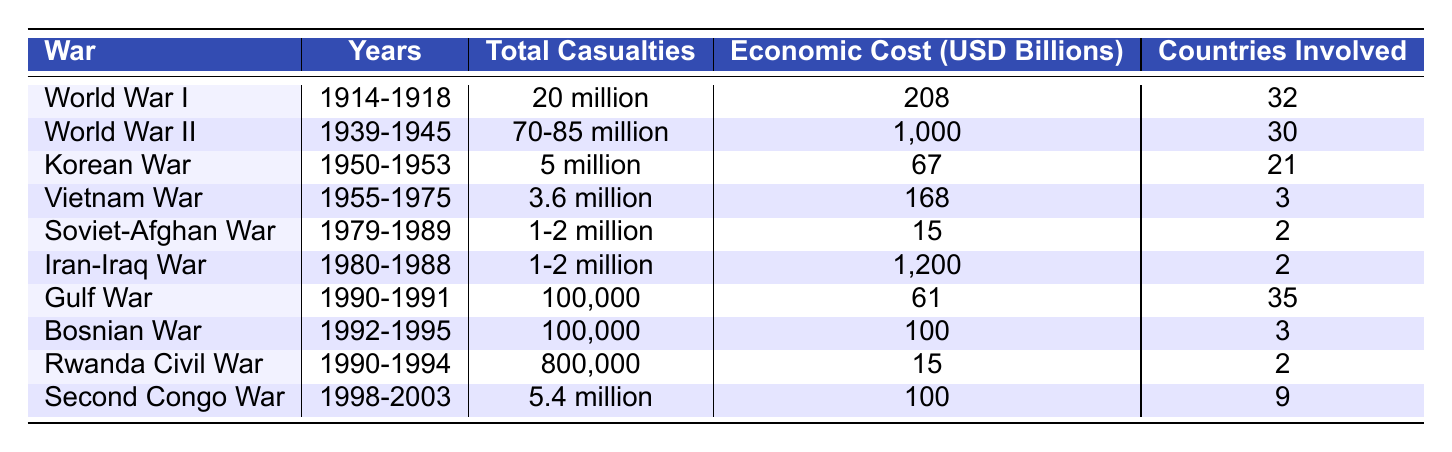What war had the highest total casualties? From the table, World War II has the total casualties listed as 70-85 million, which is higher than any other war listed.
Answer: World War II What was the economic cost of the Korean War? The table shows that the economic cost of the Korean War is listed as 67 billion USD.
Answer: 67 billion USD How many countries were involved in the Iran-Iraq War? According to the table, there were 2 countries involved in the Iran-Iraq War.
Answer: 2 What is the total casualties of the Gulf War compared to the Second Congo War? The Gulf War had 100,000 casualties, while the Second Congo War had 5.4 million. The Second Congo War had significantly more casualties than the Gulf War.
Answer: Second Congo War had more casualties What is the difference in economic cost between World War I and World War II? The economic cost of World War II is 1,000 billion USD and World War I is 208 billion USD. The difference is 1,000 - 208 = 792 billion USD.
Answer: 792 billion USD Which war had the lowest reported economic cost? Looking at the table, the Soviet-Afghan War had the lowest reported economic cost at 15 billion USD.
Answer: Soviet-Afghan War What is the average economic cost of the wars listed in the table? To find the average, we need to sum up the economic costs: 208 + 1,000 + 67 + 168 + 15 + 1,200 + 61 + 100 + 15 + 100 = 2,934 billion USD. Then, divide by the number of wars (10) to get 2,934 / 10 = 293.4 billion USD.
Answer: 293.4 billion USD Is it true that all wars listed had more than 100,000 casualties? From the table, the Gulf War and the Bosnian War both had 100,000 casualties, which means not all had more than 100,000 casualties. Therefore, it is false.
Answer: False Which war had economic costs exceeding 100 billion USD? The wars with economic costs exceeding 100 billion USD are World War II (1,000 billion USD), Iran-Iraq War (1,200 billion USD), and World War I (208 billion USD).
Answer: World War II, Iran-Iraq War, World War I What was the total number of casualties for the Vietnam War and the Korean War combined? The Vietnam War had 3.6 million casualties and the Korean War had 5 million. Combining these gives us: 3.6 + 5 = 8.6 million casualties.
Answer: 8.6 million casualties 